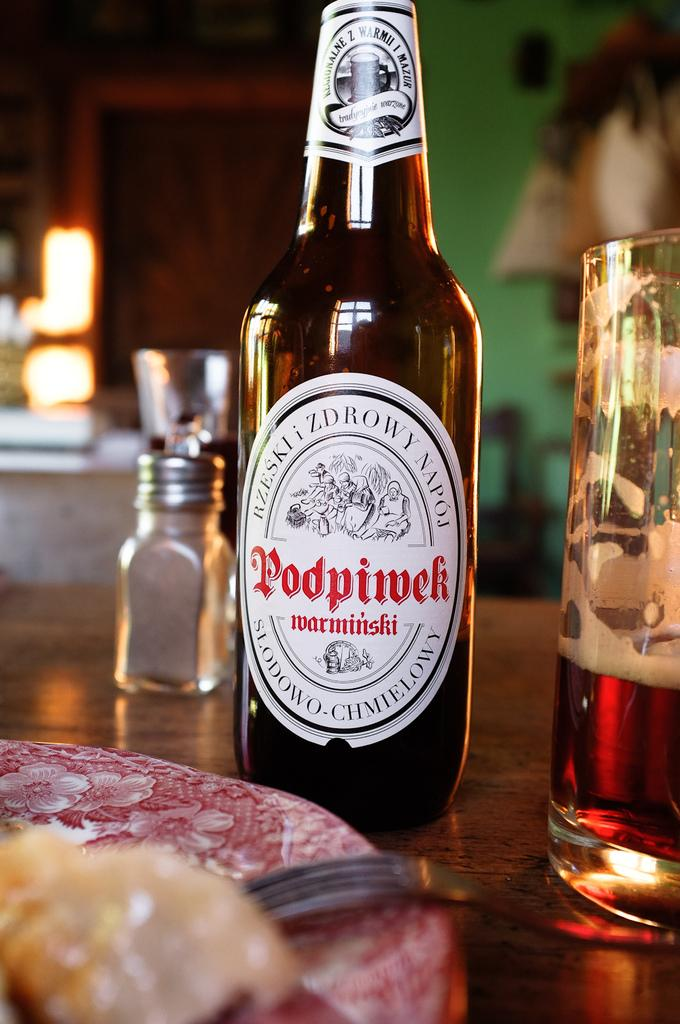<image>
Write a terse but informative summary of the picture. Beer bottle with red lettering Podpivek sitting on a table next to a salt shaker. 